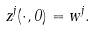Convert formula to latex. <formula><loc_0><loc_0><loc_500><loc_500>z ^ { j } ( \cdot , 0 ) = w ^ { j } .</formula> 